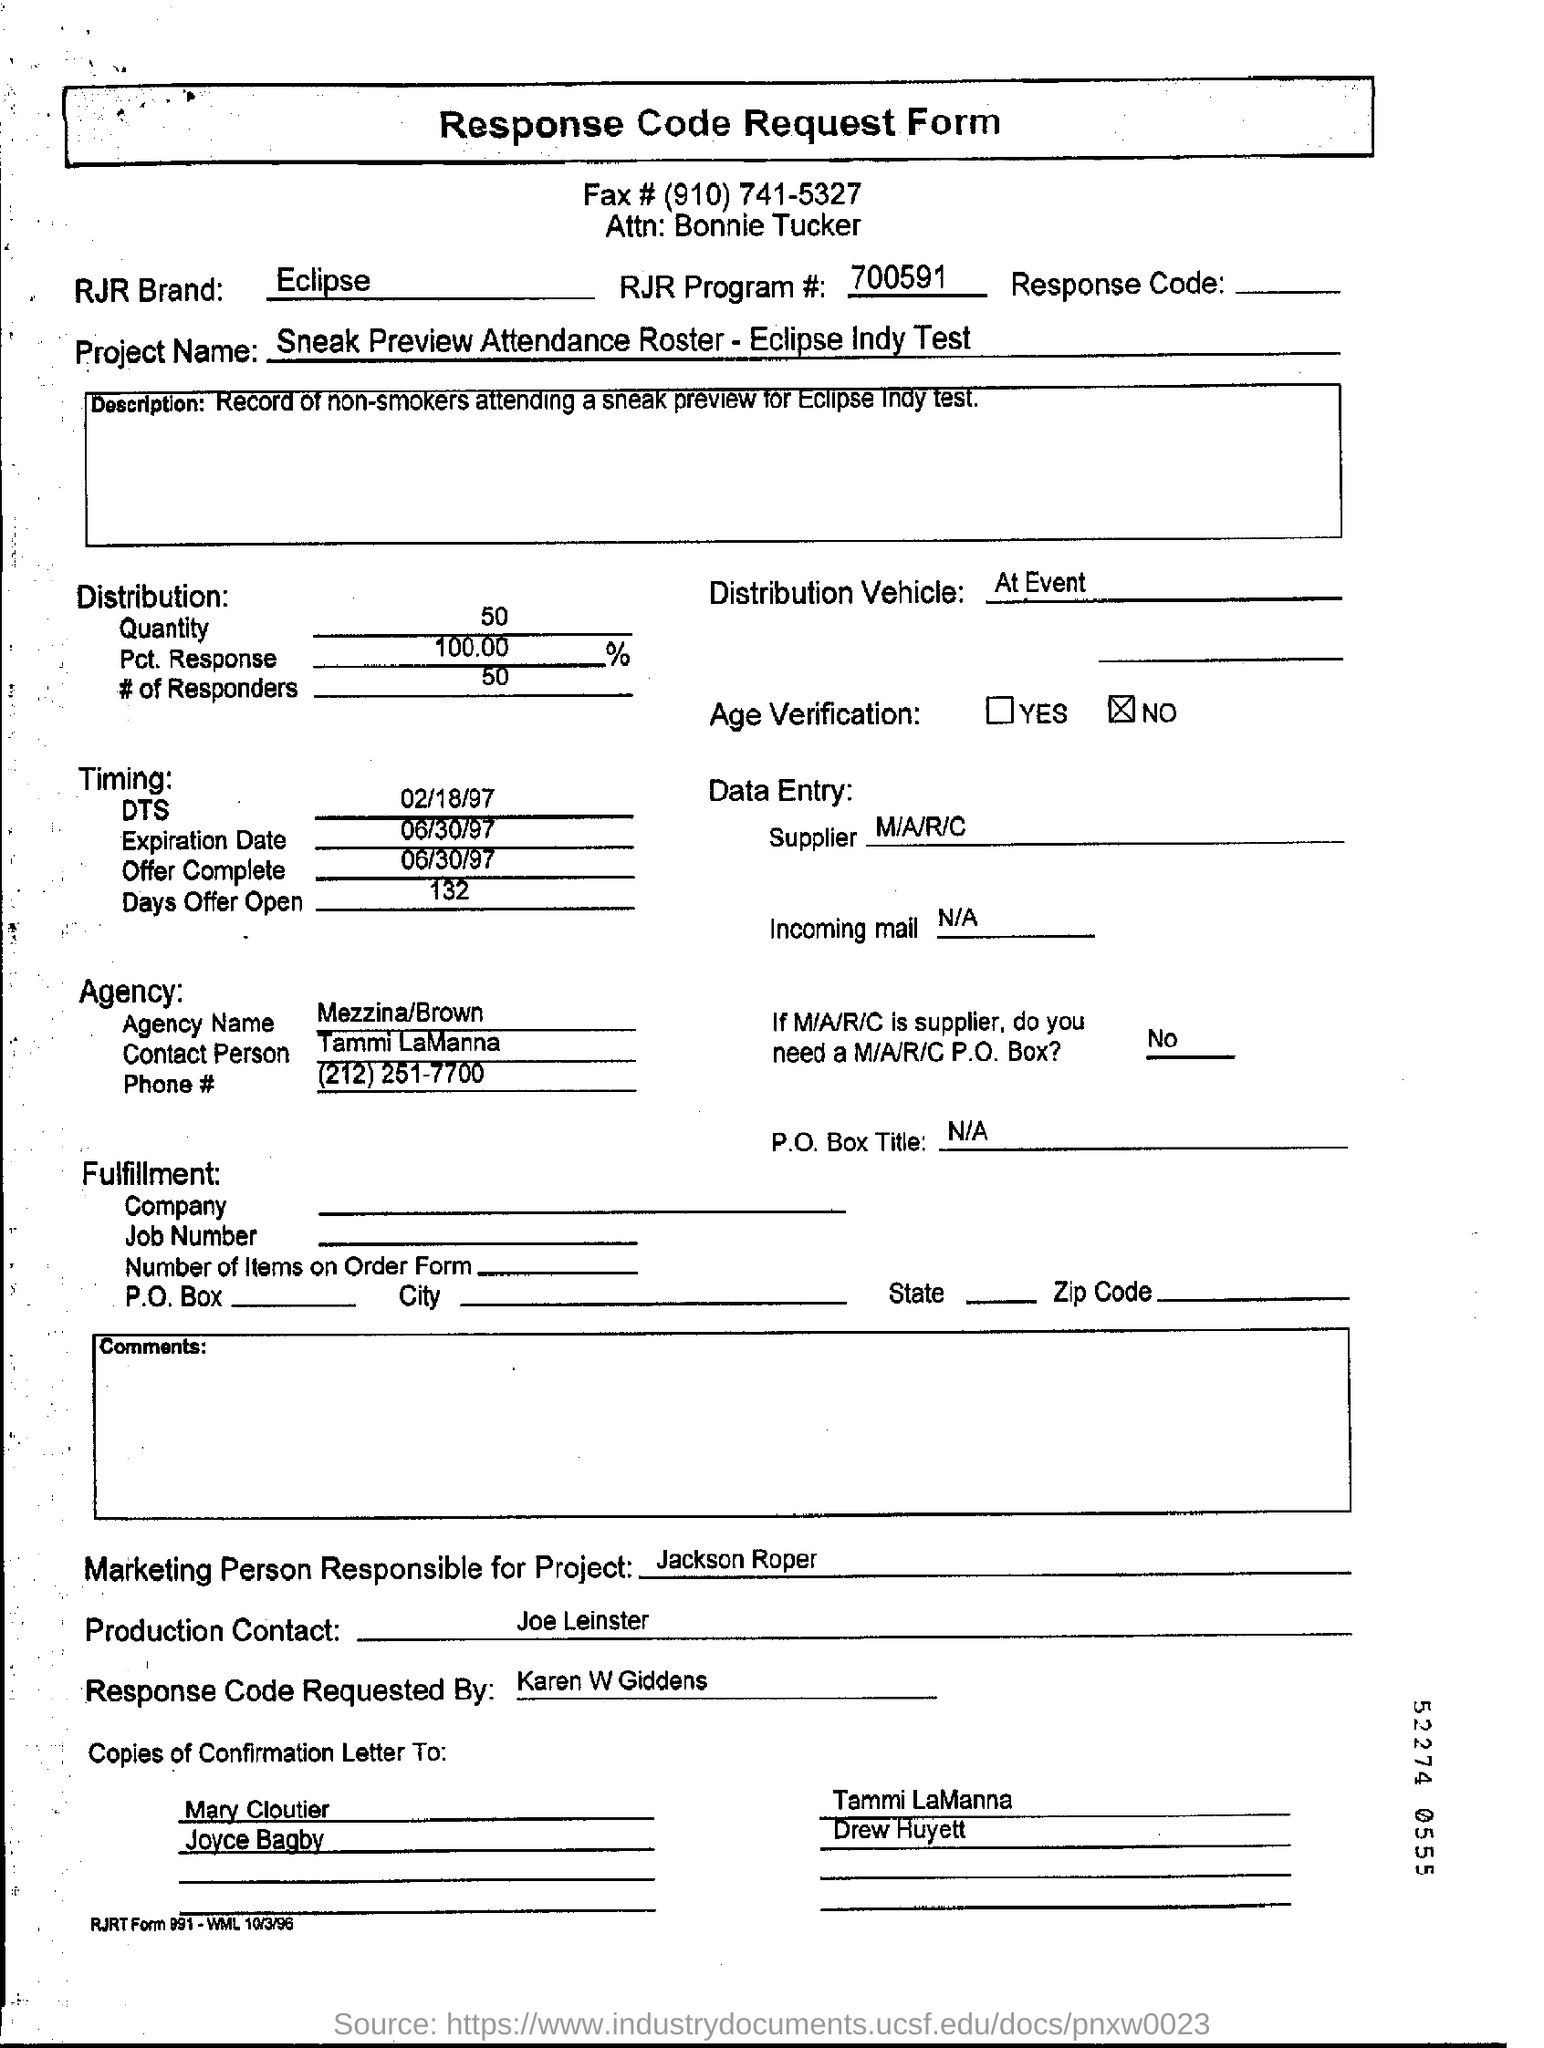Where is the distribution of vehicle ?
Your answer should be very brief. At Event. What is the Agency name?
Your answer should be very brief. Mezzina/Brown. Who is the marketing person responsible for this ?
Your response must be concise. Jackson roper. What is RJR program number ?RJ
Ensure brevity in your answer.  700591. 